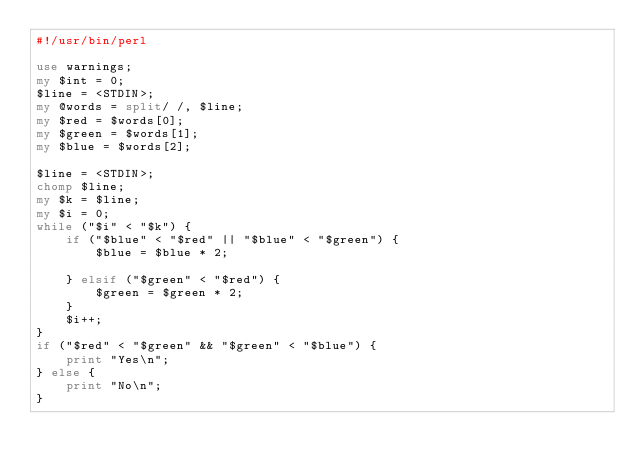<code> <loc_0><loc_0><loc_500><loc_500><_Perl_>#!/usr/bin/perl

use warnings;
my $int = 0;
$line = <STDIN>;
my @words = split/ /, $line; 
my $red = $words[0];
my $green = $words[1];
my $blue = $words[2];

$line = <STDIN>;
chomp $line;
my $k = $line;
my $i = 0;
while ("$i" < "$k") {
    if ("$blue" < "$red" || "$blue" < "$green") {
        $blue = $blue * 2;
        
    } elsif ("$green" < "$red") {
        $green = $green * 2;
    }
    $i++;
}
if ("$red" < "$green" && "$green" < "$blue") {
    print "Yes\n";
} else {
    print "No\n";
}
</code> 